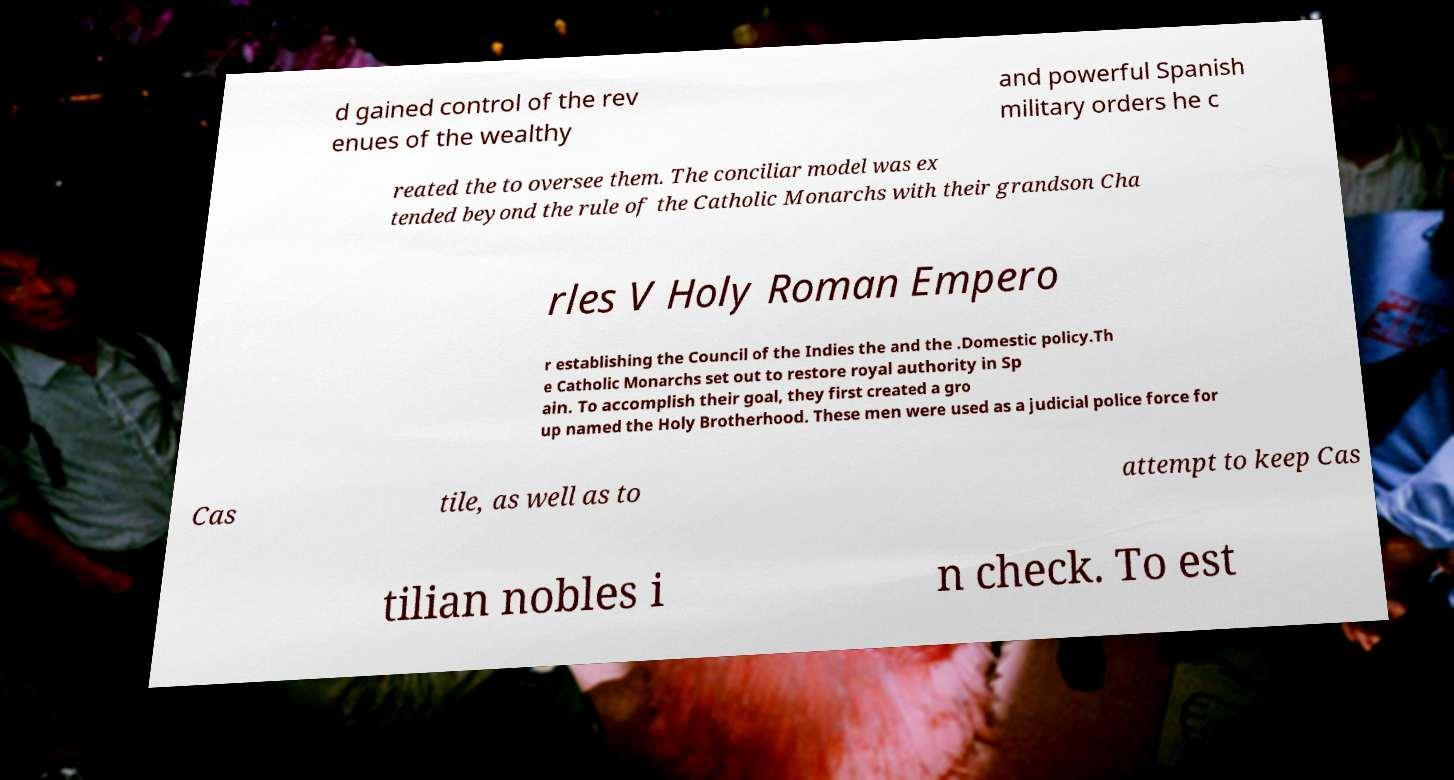There's text embedded in this image that I need extracted. Can you transcribe it verbatim? d gained control of the rev enues of the wealthy and powerful Spanish military orders he c reated the to oversee them. The conciliar model was ex tended beyond the rule of the Catholic Monarchs with their grandson Cha rles V Holy Roman Empero r establishing the Council of the Indies the and the .Domestic policy.Th e Catholic Monarchs set out to restore royal authority in Sp ain. To accomplish their goal, they first created a gro up named the Holy Brotherhood. These men were used as a judicial police force for Cas tile, as well as to attempt to keep Cas tilian nobles i n check. To est 